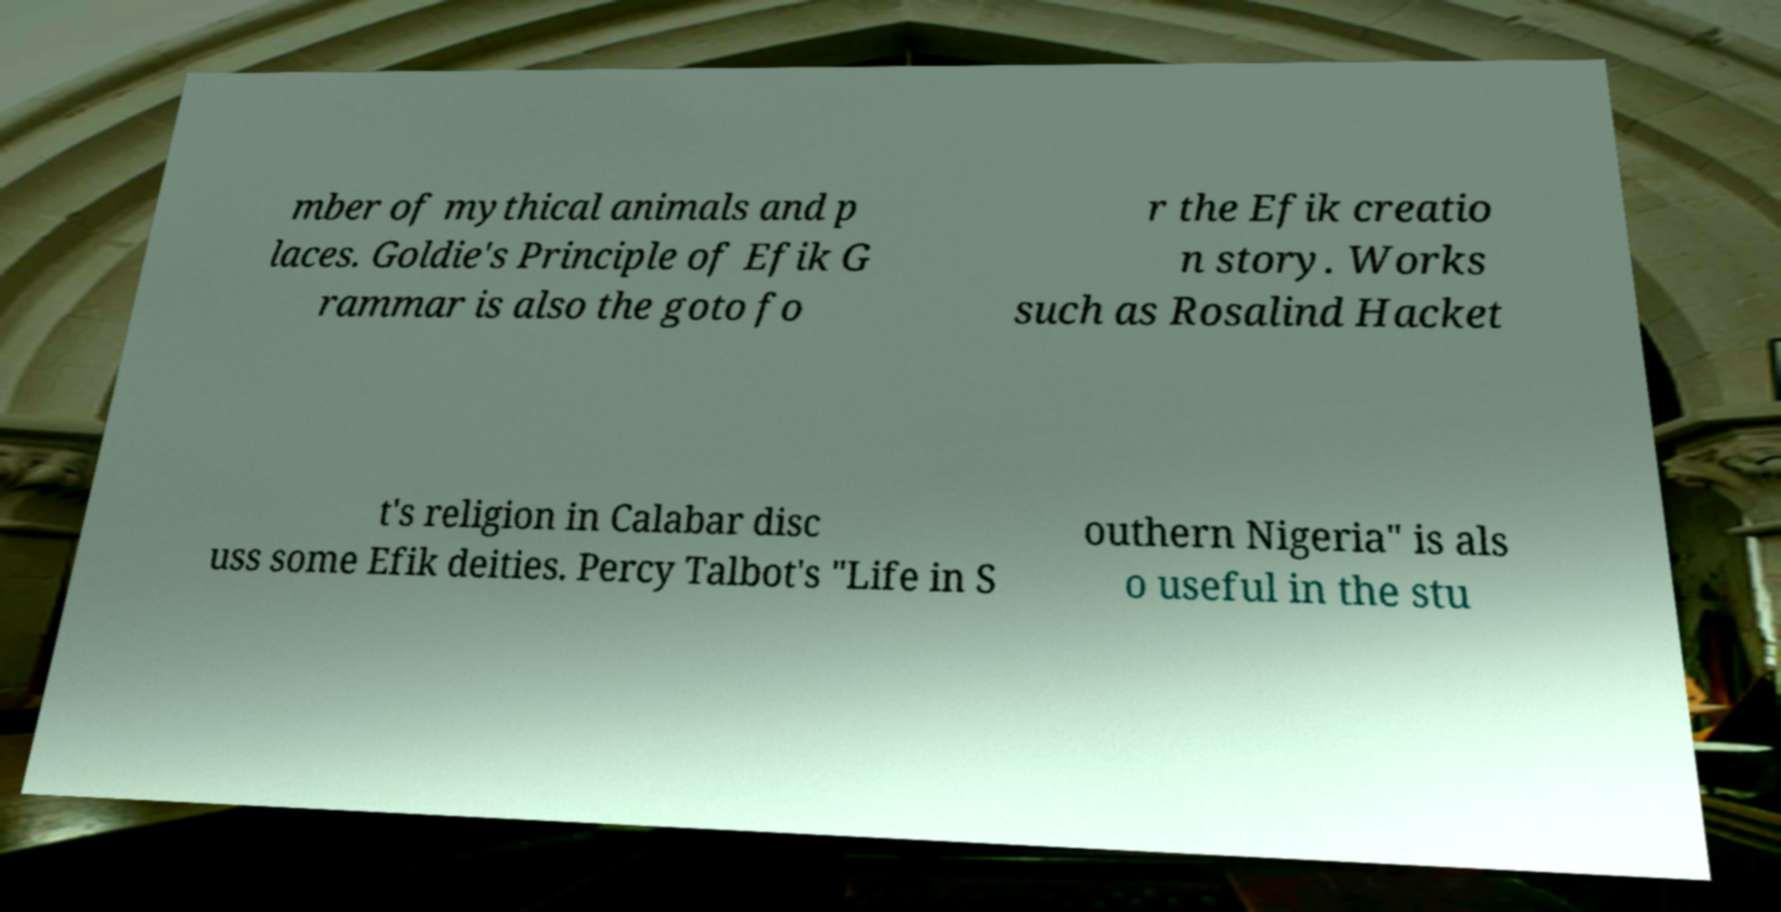Please identify and transcribe the text found in this image. mber of mythical animals and p laces. Goldie's Principle of Efik G rammar is also the goto fo r the Efik creatio n story. Works such as Rosalind Hacket t's religion in Calabar disc uss some Efik deities. Percy Talbot's "Life in S outhern Nigeria" is als o useful in the stu 